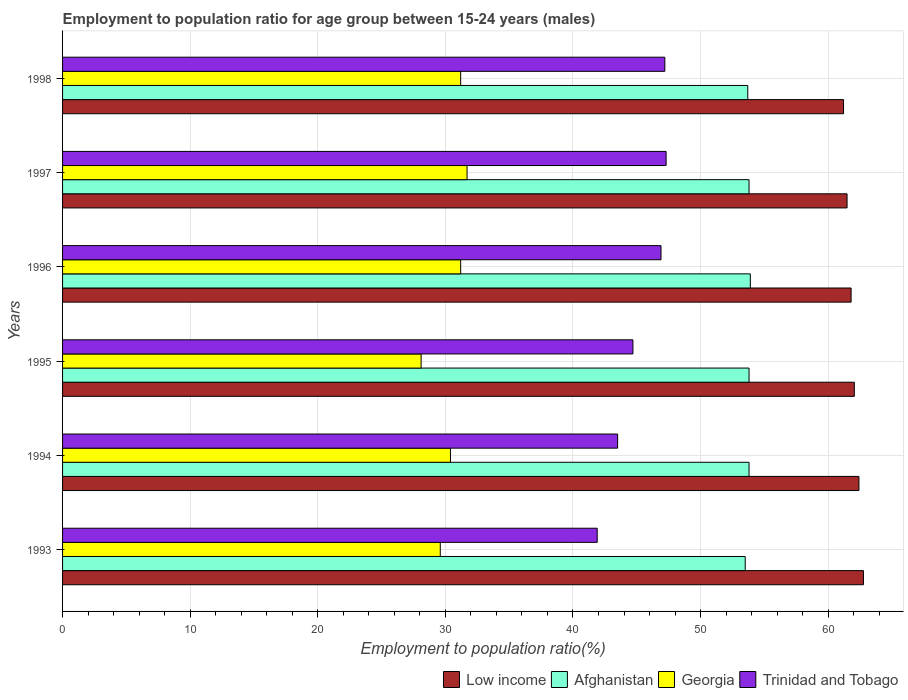Are the number of bars on each tick of the Y-axis equal?
Keep it short and to the point. Yes. How many bars are there on the 5th tick from the bottom?
Offer a terse response. 4. In how many cases, is the number of bars for a given year not equal to the number of legend labels?
Ensure brevity in your answer.  0. What is the employment to population ratio in Georgia in 1997?
Give a very brief answer. 31.7. Across all years, what is the maximum employment to population ratio in Trinidad and Tobago?
Give a very brief answer. 47.3. Across all years, what is the minimum employment to population ratio in Low income?
Make the answer very short. 61.21. What is the total employment to population ratio in Low income in the graph?
Give a very brief answer. 371.71. What is the difference between the employment to population ratio in Georgia in 1994 and that in 1998?
Keep it short and to the point. -0.8. What is the difference between the employment to population ratio in Afghanistan in 1994 and the employment to population ratio in Georgia in 1993?
Your answer should be very brief. 24.2. What is the average employment to population ratio in Low income per year?
Give a very brief answer. 61.95. In the year 1995, what is the difference between the employment to population ratio in Afghanistan and employment to population ratio in Low income?
Your answer should be compact. -8.25. In how many years, is the employment to population ratio in Afghanistan greater than 20 %?
Provide a succinct answer. 6. What is the ratio of the employment to population ratio in Low income in 1995 to that in 1996?
Keep it short and to the point. 1. Is the employment to population ratio in Trinidad and Tobago in 1994 less than that in 1995?
Provide a short and direct response. Yes. Is the difference between the employment to population ratio in Afghanistan in 1994 and 1997 greater than the difference between the employment to population ratio in Low income in 1994 and 1997?
Make the answer very short. No. What is the difference between the highest and the second highest employment to population ratio in Georgia?
Offer a very short reply. 0.5. What is the difference between the highest and the lowest employment to population ratio in Trinidad and Tobago?
Make the answer very short. 5.4. What does the 1st bar from the top in 1994 represents?
Make the answer very short. Trinidad and Tobago. Does the graph contain any zero values?
Ensure brevity in your answer.  No. Where does the legend appear in the graph?
Your response must be concise. Bottom right. How many legend labels are there?
Ensure brevity in your answer.  4. What is the title of the graph?
Ensure brevity in your answer.  Employment to population ratio for age group between 15-24 years (males). Does "Panama" appear as one of the legend labels in the graph?
Give a very brief answer. No. What is the label or title of the X-axis?
Offer a terse response. Employment to population ratio(%). What is the Employment to population ratio(%) of Low income in 1993?
Your response must be concise. 62.77. What is the Employment to population ratio(%) of Afghanistan in 1993?
Provide a short and direct response. 53.5. What is the Employment to population ratio(%) of Georgia in 1993?
Your answer should be very brief. 29.6. What is the Employment to population ratio(%) of Trinidad and Tobago in 1993?
Make the answer very short. 41.9. What is the Employment to population ratio(%) in Low income in 1994?
Make the answer very short. 62.41. What is the Employment to population ratio(%) in Afghanistan in 1994?
Offer a terse response. 53.8. What is the Employment to population ratio(%) of Georgia in 1994?
Your answer should be compact. 30.4. What is the Employment to population ratio(%) in Trinidad and Tobago in 1994?
Offer a very short reply. 43.5. What is the Employment to population ratio(%) in Low income in 1995?
Give a very brief answer. 62.05. What is the Employment to population ratio(%) of Afghanistan in 1995?
Provide a succinct answer. 53.8. What is the Employment to population ratio(%) of Georgia in 1995?
Your response must be concise. 28.1. What is the Employment to population ratio(%) in Trinidad and Tobago in 1995?
Provide a succinct answer. 44.7. What is the Employment to population ratio(%) of Low income in 1996?
Provide a short and direct response. 61.8. What is the Employment to population ratio(%) of Afghanistan in 1996?
Ensure brevity in your answer.  53.9. What is the Employment to population ratio(%) in Georgia in 1996?
Offer a terse response. 31.2. What is the Employment to population ratio(%) of Trinidad and Tobago in 1996?
Your answer should be compact. 46.9. What is the Employment to population ratio(%) in Low income in 1997?
Keep it short and to the point. 61.48. What is the Employment to population ratio(%) of Afghanistan in 1997?
Provide a succinct answer. 53.8. What is the Employment to population ratio(%) in Georgia in 1997?
Keep it short and to the point. 31.7. What is the Employment to population ratio(%) in Trinidad and Tobago in 1997?
Offer a very short reply. 47.3. What is the Employment to population ratio(%) in Low income in 1998?
Give a very brief answer. 61.21. What is the Employment to population ratio(%) in Afghanistan in 1998?
Provide a short and direct response. 53.7. What is the Employment to population ratio(%) of Georgia in 1998?
Give a very brief answer. 31.2. What is the Employment to population ratio(%) of Trinidad and Tobago in 1998?
Make the answer very short. 47.2. Across all years, what is the maximum Employment to population ratio(%) in Low income?
Offer a terse response. 62.77. Across all years, what is the maximum Employment to population ratio(%) in Afghanistan?
Provide a short and direct response. 53.9. Across all years, what is the maximum Employment to population ratio(%) in Georgia?
Provide a succinct answer. 31.7. Across all years, what is the maximum Employment to population ratio(%) in Trinidad and Tobago?
Provide a short and direct response. 47.3. Across all years, what is the minimum Employment to population ratio(%) of Low income?
Provide a succinct answer. 61.21. Across all years, what is the minimum Employment to population ratio(%) of Afghanistan?
Provide a succinct answer. 53.5. Across all years, what is the minimum Employment to population ratio(%) of Georgia?
Provide a succinct answer. 28.1. Across all years, what is the minimum Employment to population ratio(%) of Trinidad and Tobago?
Provide a succinct answer. 41.9. What is the total Employment to population ratio(%) of Low income in the graph?
Offer a very short reply. 371.71. What is the total Employment to population ratio(%) of Afghanistan in the graph?
Offer a very short reply. 322.5. What is the total Employment to population ratio(%) in Georgia in the graph?
Make the answer very short. 182.2. What is the total Employment to population ratio(%) in Trinidad and Tobago in the graph?
Your response must be concise. 271.5. What is the difference between the Employment to population ratio(%) of Low income in 1993 and that in 1994?
Your response must be concise. 0.35. What is the difference between the Employment to population ratio(%) of Georgia in 1993 and that in 1994?
Offer a terse response. -0.8. What is the difference between the Employment to population ratio(%) of Trinidad and Tobago in 1993 and that in 1994?
Keep it short and to the point. -1.6. What is the difference between the Employment to population ratio(%) in Low income in 1993 and that in 1995?
Your answer should be very brief. 0.72. What is the difference between the Employment to population ratio(%) of Trinidad and Tobago in 1993 and that in 1995?
Offer a very short reply. -2.8. What is the difference between the Employment to population ratio(%) of Low income in 1993 and that in 1996?
Give a very brief answer. 0.97. What is the difference between the Employment to population ratio(%) in Georgia in 1993 and that in 1996?
Your answer should be compact. -1.6. What is the difference between the Employment to population ratio(%) in Trinidad and Tobago in 1993 and that in 1996?
Provide a succinct answer. -5. What is the difference between the Employment to population ratio(%) in Low income in 1993 and that in 1997?
Offer a very short reply. 1.28. What is the difference between the Employment to population ratio(%) of Afghanistan in 1993 and that in 1997?
Offer a very short reply. -0.3. What is the difference between the Employment to population ratio(%) in Low income in 1993 and that in 1998?
Your response must be concise. 1.56. What is the difference between the Employment to population ratio(%) of Georgia in 1993 and that in 1998?
Keep it short and to the point. -1.6. What is the difference between the Employment to population ratio(%) in Trinidad and Tobago in 1993 and that in 1998?
Keep it short and to the point. -5.3. What is the difference between the Employment to population ratio(%) of Low income in 1994 and that in 1995?
Provide a short and direct response. 0.36. What is the difference between the Employment to population ratio(%) in Afghanistan in 1994 and that in 1995?
Your answer should be compact. 0. What is the difference between the Employment to population ratio(%) in Trinidad and Tobago in 1994 and that in 1995?
Your response must be concise. -1.2. What is the difference between the Employment to population ratio(%) in Low income in 1994 and that in 1996?
Ensure brevity in your answer.  0.61. What is the difference between the Employment to population ratio(%) of Afghanistan in 1994 and that in 1996?
Your answer should be compact. -0.1. What is the difference between the Employment to population ratio(%) in Low income in 1994 and that in 1997?
Ensure brevity in your answer.  0.93. What is the difference between the Employment to population ratio(%) in Afghanistan in 1994 and that in 1997?
Your answer should be very brief. 0. What is the difference between the Employment to population ratio(%) of Georgia in 1994 and that in 1997?
Provide a short and direct response. -1.3. What is the difference between the Employment to population ratio(%) of Low income in 1994 and that in 1998?
Offer a very short reply. 1.21. What is the difference between the Employment to population ratio(%) in Georgia in 1994 and that in 1998?
Provide a succinct answer. -0.8. What is the difference between the Employment to population ratio(%) of Low income in 1995 and that in 1996?
Your answer should be compact. 0.25. What is the difference between the Employment to population ratio(%) of Georgia in 1995 and that in 1996?
Give a very brief answer. -3.1. What is the difference between the Employment to population ratio(%) in Low income in 1995 and that in 1997?
Offer a very short reply. 0.57. What is the difference between the Employment to population ratio(%) in Low income in 1995 and that in 1998?
Provide a short and direct response. 0.84. What is the difference between the Employment to population ratio(%) in Afghanistan in 1995 and that in 1998?
Keep it short and to the point. 0.1. What is the difference between the Employment to population ratio(%) of Trinidad and Tobago in 1995 and that in 1998?
Give a very brief answer. -2.5. What is the difference between the Employment to population ratio(%) of Low income in 1996 and that in 1997?
Offer a very short reply. 0.32. What is the difference between the Employment to population ratio(%) in Georgia in 1996 and that in 1997?
Make the answer very short. -0.5. What is the difference between the Employment to population ratio(%) in Trinidad and Tobago in 1996 and that in 1997?
Your answer should be compact. -0.4. What is the difference between the Employment to population ratio(%) of Low income in 1996 and that in 1998?
Provide a short and direct response. 0.59. What is the difference between the Employment to population ratio(%) in Afghanistan in 1996 and that in 1998?
Provide a succinct answer. 0.2. What is the difference between the Employment to population ratio(%) in Low income in 1997 and that in 1998?
Your answer should be compact. 0.28. What is the difference between the Employment to population ratio(%) in Afghanistan in 1997 and that in 1998?
Provide a short and direct response. 0.1. What is the difference between the Employment to population ratio(%) of Georgia in 1997 and that in 1998?
Your answer should be compact. 0.5. What is the difference between the Employment to population ratio(%) in Low income in 1993 and the Employment to population ratio(%) in Afghanistan in 1994?
Offer a very short reply. 8.97. What is the difference between the Employment to population ratio(%) in Low income in 1993 and the Employment to population ratio(%) in Georgia in 1994?
Your answer should be compact. 32.37. What is the difference between the Employment to population ratio(%) of Low income in 1993 and the Employment to population ratio(%) of Trinidad and Tobago in 1994?
Your response must be concise. 19.27. What is the difference between the Employment to population ratio(%) in Afghanistan in 1993 and the Employment to population ratio(%) in Georgia in 1994?
Keep it short and to the point. 23.1. What is the difference between the Employment to population ratio(%) of Georgia in 1993 and the Employment to population ratio(%) of Trinidad and Tobago in 1994?
Offer a terse response. -13.9. What is the difference between the Employment to population ratio(%) in Low income in 1993 and the Employment to population ratio(%) in Afghanistan in 1995?
Provide a short and direct response. 8.97. What is the difference between the Employment to population ratio(%) of Low income in 1993 and the Employment to population ratio(%) of Georgia in 1995?
Give a very brief answer. 34.67. What is the difference between the Employment to population ratio(%) of Low income in 1993 and the Employment to population ratio(%) of Trinidad and Tobago in 1995?
Keep it short and to the point. 18.07. What is the difference between the Employment to population ratio(%) of Afghanistan in 1993 and the Employment to population ratio(%) of Georgia in 1995?
Your response must be concise. 25.4. What is the difference between the Employment to population ratio(%) in Georgia in 1993 and the Employment to population ratio(%) in Trinidad and Tobago in 1995?
Your answer should be very brief. -15.1. What is the difference between the Employment to population ratio(%) in Low income in 1993 and the Employment to population ratio(%) in Afghanistan in 1996?
Offer a terse response. 8.87. What is the difference between the Employment to population ratio(%) of Low income in 1993 and the Employment to population ratio(%) of Georgia in 1996?
Your answer should be very brief. 31.57. What is the difference between the Employment to population ratio(%) in Low income in 1993 and the Employment to population ratio(%) in Trinidad and Tobago in 1996?
Provide a succinct answer. 15.87. What is the difference between the Employment to population ratio(%) in Afghanistan in 1993 and the Employment to population ratio(%) in Georgia in 1996?
Your answer should be very brief. 22.3. What is the difference between the Employment to population ratio(%) in Georgia in 1993 and the Employment to population ratio(%) in Trinidad and Tobago in 1996?
Ensure brevity in your answer.  -17.3. What is the difference between the Employment to population ratio(%) of Low income in 1993 and the Employment to population ratio(%) of Afghanistan in 1997?
Make the answer very short. 8.97. What is the difference between the Employment to population ratio(%) in Low income in 1993 and the Employment to population ratio(%) in Georgia in 1997?
Your answer should be compact. 31.07. What is the difference between the Employment to population ratio(%) of Low income in 1993 and the Employment to population ratio(%) of Trinidad and Tobago in 1997?
Your answer should be compact. 15.47. What is the difference between the Employment to population ratio(%) in Afghanistan in 1993 and the Employment to population ratio(%) in Georgia in 1997?
Make the answer very short. 21.8. What is the difference between the Employment to population ratio(%) in Georgia in 1993 and the Employment to population ratio(%) in Trinidad and Tobago in 1997?
Your answer should be compact. -17.7. What is the difference between the Employment to population ratio(%) in Low income in 1993 and the Employment to population ratio(%) in Afghanistan in 1998?
Provide a succinct answer. 9.07. What is the difference between the Employment to population ratio(%) in Low income in 1993 and the Employment to population ratio(%) in Georgia in 1998?
Your answer should be very brief. 31.57. What is the difference between the Employment to population ratio(%) of Low income in 1993 and the Employment to population ratio(%) of Trinidad and Tobago in 1998?
Your response must be concise. 15.57. What is the difference between the Employment to population ratio(%) of Afghanistan in 1993 and the Employment to population ratio(%) of Georgia in 1998?
Provide a short and direct response. 22.3. What is the difference between the Employment to population ratio(%) of Afghanistan in 1993 and the Employment to population ratio(%) of Trinidad and Tobago in 1998?
Your answer should be compact. 6.3. What is the difference between the Employment to population ratio(%) of Georgia in 1993 and the Employment to population ratio(%) of Trinidad and Tobago in 1998?
Ensure brevity in your answer.  -17.6. What is the difference between the Employment to population ratio(%) in Low income in 1994 and the Employment to population ratio(%) in Afghanistan in 1995?
Your answer should be very brief. 8.61. What is the difference between the Employment to population ratio(%) of Low income in 1994 and the Employment to population ratio(%) of Georgia in 1995?
Your answer should be compact. 34.31. What is the difference between the Employment to population ratio(%) in Low income in 1994 and the Employment to population ratio(%) in Trinidad and Tobago in 1995?
Give a very brief answer. 17.71. What is the difference between the Employment to population ratio(%) in Afghanistan in 1994 and the Employment to population ratio(%) in Georgia in 1995?
Give a very brief answer. 25.7. What is the difference between the Employment to population ratio(%) in Georgia in 1994 and the Employment to population ratio(%) in Trinidad and Tobago in 1995?
Your answer should be very brief. -14.3. What is the difference between the Employment to population ratio(%) of Low income in 1994 and the Employment to population ratio(%) of Afghanistan in 1996?
Your answer should be very brief. 8.51. What is the difference between the Employment to population ratio(%) of Low income in 1994 and the Employment to population ratio(%) of Georgia in 1996?
Provide a short and direct response. 31.21. What is the difference between the Employment to population ratio(%) in Low income in 1994 and the Employment to population ratio(%) in Trinidad and Tobago in 1996?
Offer a terse response. 15.51. What is the difference between the Employment to population ratio(%) of Afghanistan in 1994 and the Employment to population ratio(%) of Georgia in 1996?
Offer a terse response. 22.6. What is the difference between the Employment to population ratio(%) in Georgia in 1994 and the Employment to population ratio(%) in Trinidad and Tobago in 1996?
Keep it short and to the point. -16.5. What is the difference between the Employment to population ratio(%) in Low income in 1994 and the Employment to population ratio(%) in Afghanistan in 1997?
Your answer should be very brief. 8.61. What is the difference between the Employment to population ratio(%) in Low income in 1994 and the Employment to population ratio(%) in Georgia in 1997?
Offer a terse response. 30.71. What is the difference between the Employment to population ratio(%) of Low income in 1994 and the Employment to population ratio(%) of Trinidad and Tobago in 1997?
Make the answer very short. 15.11. What is the difference between the Employment to population ratio(%) in Afghanistan in 1994 and the Employment to population ratio(%) in Georgia in 1997?
Ensure brevity in your answer.  22.1. What is the difference between the Employment to population ratio(%) of Georgia in 1994 and the Employment to population ratio(%) of Trinidad and Tobago in 1997?
Offer a very short reply. -16.9. What is the difference between the Employment to population ratio(%) of Low income in 1994 and the Employment to population ratio(%) of Afghanistan in 1998?
Offer a very short reply. 8.71. What is the difference between the Employment to population ratio(%) in Low income in 1994 and the Employment to population ratio(%) in Georgia in 1998?
Your response must be concise. 31.21. What is the difference between the Employment to population ratio(%) of Low income in 1994 and the Employment to population ratio(%) of Trinidad and Tobago in 1998?
Offer a terse response. 15.21. What is the difference between the Employment to population ratio(%) in Afghanistan in 1994 and the Employment to population ratio(%) in Georgia in 1998?
Keep it short and to the point. 22.6. What is the difference between the Employment to population ratio(%) of Georgia in 1994 and the Employment to population ratio(%) of Trinidad and Tobago in 1998?
Ensure brevity in your answer.  -16.8. What is the difference between the Employment to population ratio(%) in Low income in 1995 and the Employment to population ratio(%) in Afghanistan in 1996?
Your answer should be very brief. 8.15. What is the difference between the Employment to population ratio(%) of Low income in 1995 and the Employment to population ratio(%) of Georgia in 1996?
Your answer should be compact. 30.85. What is the difference between the Employment to population ratio(%) in Low income in 1995 and the Employment to population ratio(%) in Trinidad and Tobago in 1996?
Offer a very short reply. 15.15. What is the difference between the Employment to population ratio(%) of Afghanistan in 1995 and the Employment to population ratio(%) of Georgia in 1996?
Make the answer very short. 22.6. What is the difference between the Employment to population ratio(%) of Georgia in 1995 and the Employment to population ratio(%) of Trinidad and Tobago in 1996?
Ensure brevity in your answer.  -18.8. What is the difference between the Employment to population ratio(%) of Low income in 1995 and the Employment to population ratio(%) of Afghanistan in 1997?
Offer a terse response. 8.25. What is the difference between the Employment to population ratio(%) in Low income in 1995 and the Employment to population ratio(%) in Georgia in 1997?
Make the answer very short. 30.35. What is the difference between the Employment to population ratio(%) in Low income in 1995 and the Employment to population ratio(%) in Trinidad and Tobago in 1997?
Your answer should be compact. 14.75. What is the difference between the Employment to population ratio(%) of Afghanistan in 1995 and the Employment to population ratio(%) of Georgia in 1997?
Give a very brief answer. 22.1. What is the difference between the Employment to population ratio(%) of Georgia in 1995 and the Employment to population ratio(%) of Trinidad and Tobago in 1997?
Ensure brevity in your answer.  -19.2. What is the difference between the Employment to population ratio(%) in Low income in 1995 and the Employment to population ratio(%) in Afghanistan in 1998?
Your answer should be compact. 8.35. What is the difference between the Employment to population ratio(%) in Low income in 1995 and the Employment to population ratio(%) in Georgia in 1998?
Your response must be concise. 30.85. What is the difference between the Employment to population ratio(%) of Low income in 1995 and the Employment to population ratio(%) of Trinidad and Tobago in 1998?
Your response must be concise. 14.85. What is the difference between the Employment to population ratio(%) in Afghanistan in 1995 and the Employment to population ratio(%) in Georgia in 1998?
Provide a succinct answer. 22.6. What is the difference between the Employment to population ratio(%) of Georgia in 1995 and the Employment to population ratio(%) of Trinidad and Tobago in 1998?
Offer a terse response. -19.1. What is the difference between the Employment to population ratio(%) of Low income in 1996 and the Employment to population ratio(%) of Afghanistan in 1997?
Your answer should be very brief. 8. What is the difference between the Employment to population ratio(%) in Low income in 1996 and the Employment to population ratio(%) in Georgia in 1997?
Make the answer very short. 30.1. What is the difference between the Employment to population ratio(%) of Low income in 1996 and the Employment to population ratio(%) of Trinidad and Tobago in 1997?
Your response must be concise. 14.5. What is the difference between the Employment to population ratio(%) in Afghanistan in 1996 and the Employment to population ratio(%) in Georgia in 1997?
Make the answer very short. 22.2. What is the difference between the Employment to population ratio(%) of Afghanistan in 1996 and the Employment to population ratio(%) of Trinidad and Tobago in 1997?
Ensure brevity in your answer.  6.6. What is the difference between the Employment to population ratio(%) in Georgia in 1996 and the Employment to population ratio(%) in Trinidad and Tobago in 1997?
Your answer should be very brief. -16.1. What is the difference between the Employment to population ratio(%) in Low income in 1996 and the Employment to population ratio(%) in Afghanistan in 1998?
Provide a succinct answer. 8.1. What is the difference between the Employment to population ratio(%) in Low income in 1996 and the Employment to population ratio(%) in Georgia in 1998?
Make the answer very short. 30.6. What is the difference between the Employment to population ratio(%) in Low income in 1996 and the Employment to population ratio(%) in Trinidad and Tobago in 1998?
Your response must be concise. 14.6. What is the difference between the Employment to population ratio(%) of Afghanistan in 1996 and the Employment to population ratio(%) of Georgia in 1998?
Provide a short and direct response. 22.7. What is the difference between the Employment to population ratio(%) in Afghanistan in 1996 and the Employment to population ratio(%) in Trinidad and Tobago in 1998?
Provide a succinct answer. 6.7. What is the difference between the Employment to population ratio(%) in Georgia in 1996 and the Employment to population ratio(%) in Trinidad and Tobago in 1998?
Your answer should be compact. -16. What is the difference between the Employment to population ratio(%) of Low income in 1997 and the Employment to population ratio(%) of Afghanistan in 1998?
Keep it short and to the point. 7.78. What is the difference between the Employment to population ratio(%) in Low income in 1997 and the Employment to population ratio(%) in Georgia in 1998?
Your answer should be compact. 30.28. What is the difference between the Employment to population ratio(%) of Low income in 1997 and the Employment to population ratio(%) of Trinidad and Tobago in 1998?
Your answer should be very brief. 14.28. What is the difference between the Employment to population ratio(%) of Afghanistan in 1997 and the Employment to population ratio(%) of Georgia in 1998?
Your response must be concise. 22.6. What is the difference between the Employment to population ratio(%) in Georgia in 1997 and the Employment to population ratio(%) in Trinidad and Tobago in 1998?
Your answer should be compact. -15.5. What is the average Employment to population ratio(%) of Low income per year?
Ensure brevity in your answer.  61.95. What is the average Employment to population ratio(%) in Afghanistan per year?
Your answer should be compact. 53.75. What is the average Employment to population ratio(%) in Georgia per year?
Keep it short and to the point. 30.37. What is the average Employment to population ratio(%) of Trinidad and Tobago per year?
Give a very brief answer. 45.25. In the year 1993, what is the difference between the Employment to population ratio(%) of Low income and Employment to population ratio(%) of Afghanistan?
Keep it short and to the point. 9.27. In the year 1993, what is the difference between the Employment to population ratio(%) in Low income and Employment to population ratio(%) in Georgia?
Offer a very short reply. 33.17. In the year 1993, what is the difference between the Employment to population ratio(%) of Low income and Employment to population ratio(%) of Trinidad and Tobago?
Give a very brief answer. 20.87. In the year 1993, what is the difference between the Employment to population ratio(%) of Afghanistan and Employment to population ratio(%) of Georgia?
Ensure brevity in your answer.  23.9. In the year 1993, what is the difference between the Employment to population ratio(%) in Georgia and Employment to population ratio(%) in Trinidad and Tobago?
Provide a succinct answer. -12.3. In the year 1994, what is the difference between the Employment to population ratio(%) in Low income and Employment to population ratio(%) in Afghanistan?
Offer a very short reply. 8.61. In the year 1994, what is the difference between the Employment to population ratio(%) of Low income and Employment to population ratio(%) of Georgia?
Provide a short and direct response. 32.01. In the year 1994, what is the difference between the Employment to population ratio(%) of Low income and Employment to population ratio(%) of Trinidad and Tobago?
Your response must be concise. 18.91. In the year 1994, what is the difference between the Employment to population ratio(%) of Afghanistan and Employment to population ratio(%) of Georgia?
Offer a terse response. 23.4. In the year 1994, what is the difference between the Employment to population ratio(%) in Afghanistan and Employment to population ratio(%) in Trinidad and Tobago?
Keep it short and to the point. 10.3. In the year 1995, what is the difference between the Employment to population ratio(%) of Low income and Employment to population ratio(%) of Afghanistan?
Give a very brief answer. 8.25. In the year 1995, what is the difference between the Employment to population ratio(%) of Low income and Employment to population ratio(%) of Georgia?
Provide a succinct answer. 33.95. In the year 1995, what is the difference between the Employment to population ratio(%) of Low income and Employment to population ratio(%) of Trinidad and Tobago?
Make the answer very short. 17.35. In the year 1995, what is the difference between the Employment to population ratio(%) in Afghanistan and Employment to population ratio(%) in Georgia?
Your answer should be very brief. 25.7. In the year 1995, what is the difference between the Employment to population ratio(%) of Georgia and Employment to population ratio(%) of Trinidad and Tobago?
Your response must be concise. -16.6. In the year 1996, what is the difference between the Employment to population ratio(%) of Low income and Employment to population ratio(%) of Afghanistan?
Offer a very short reply. 7.9. In the year 1996, what is the difference between the Employment to population ratio(%) in Low income and Employment to population ratio(%) in Georgia?
Give a very brief answer. 30.6. In the year 1996, what is the difference between the Employment to population ratio(%) in Low income and Employment to population ratio(%) in Trinidad and Tobago?
Ensure brevity in your answer.  14.9. In the year 1996, what is the difference between the Employment to population ratio(%) in Afghanistan and Employment to population ratio(%) in Georgia?
Provide a succinct answer. 22.7. In the year 1996, what is the difference between the Employment to population ratio(%) of Afghanistan and Employment to population ratio(%) of Trinidad and Tobago?
Give a very brief answer. 7. In the year 1996, what is the difference between the Employment to population ratio(%) of Georgia and Employment to population ratio(%) of Trinidad and Tobago?
Keep it short and to the point. -15.7. In the year 1997, what is the difference between the Employment to population ratio(%) in Low income and Employment to population ratio(%) in Afghanistan?
Ensure brevity in your answer.  7.68. In the year 1997, what is the difference between the Employment to population ratio(%) of Low income and Employment to population ratio(%) of Georgia?
Your response must be concise. 29.78. In the year 1997, what is the difference between the Employment to population ratio(%) in Low income and Employment to population ratio(%) in Trinidad and Tobago?
Provide a succinct answer. 14.18. In the year 1997, what is the difference between the Employment to population ratio(%) of Afghanistan and Employment to population ratio(%) of Georgia?
Provide a short and direct response. 22.1. In the year 1997, what is the difference between the Employment to population ratio(%) of Afghanistan and Employment to population ratio(%) of Trinidad and Tobago?
Give a very brief answer. 6.5. In the year 1997, what is the difference between the Employment to population ratio(%) of Georgia and Employment to population ratio(%) of Trinidad and Tobago?
Give a very brief answer. -15.6. In the year 1998, what is the difference between the Employment to population ratio(%) of Low income and Employment to population ratio(%) of Afghanistan?
Offer a terse response. 7.51. In the year 1998, what is the difference between the Employment to population ratio(%) in Low income and Employment to population ratio(%) in Georgia?
Keep it short and to the point. 30.01. In the year 1998, what is the difference between the Employment to population ratio(%) of Low income and Employment to population ratio(%) of Trinidad and Tobago?
Make the answer very short. 14.01. In the year 1998, what is the difference between the Employment to population ratio(%) of Afghanistan and Employment to population ratio(%) of Georgia?
Your response must be concise. 22.5. In the year 1998, what is the difference between the Employment to population ratio(%) in Georgia and Employment to population ratio(%) in Trinidad and Tobago?
Make the answer very short. -16. What is the ratio of the Employment to population ratio(%) in Afghanistan in 1993 to that in 1994?
Give a very brief answer. 0.99. What is the ratio of the Employment to population ratio(%) of Georgia in 1993 to that in 1994?
Offer a very short reply. 0.97. What is the ratio of the Employment to population ratio(%) in Trinidad and Tobago in 1993 to that in 1994?
Your answer should be compact. 0.96. What is the ratio of the Employment to population ratio(%) of Low income in 1993 to that in 1995?
Provide a short and direct response. 1.01. What is the ratio of the Employment to population ratio(%) of Georgia in 1993 to that in 1995?
Keep it short and to the point. 1.05. What is the ratio of the Employment to population ratio(%) in Trinidad and Tobago in 1993 to that in 1995?
Offer a very short reply. 0.94. What is the ratio of the Employment to population ratio(%) in Low income in 1993 to that in 1996?
Offer a terse response. 1.02. What is the ratio of the Employment to population ratio(%) of Georgia in 1993 to that in 1996?
Your answer should be compact. 0.95. What is the ratio of the Employment to population ratio(%) in Trinidad and Tobago in 1993 to that in 1996?
Your answer should be very brief. 0.89. What is the ratio of the Employment to population ratio(%) in Low income in 1993 to that in 1997?
Your answer should be very brief. 1.02. What is the ratio of the Employment to population ratio(%) in Afghanistan in 1993 to that in 1997?
Ensure brevity in your answer.  0.99. What is the ratio of the Employment to population ratio(%) of Georgia in 1993 to that in 1997?
Offer a terse response. 0.93. What is the ratio of the Employment to population ratio(%) of Trinidad and Tobago in 1993 to that in 1997?
Offer a terse response. 0.89. What is the ratio of the Employment to population ratio(%) in Low income in 1993 to that in 1998?
Your response must be concise. 1.03. What is the ratio of the Employment to population ratio(%) in Afghanistan in 1993 to that in 1998?
Offer a terse response. 1. What is the ratio of the Employment to population ratio(%) in Georgia in 1993 to that in 1998?
Offer a very short reply. 0.95. What is the ratio of the Employment to population ratio(%) of Trinidad and Tobago in 1993 to that in 1998?
Provide a short and direct response. 0.89. What is the ratio of the Employment to population ratio(%) in Georgia in 1994 to that in 1995?
Give a very brief answer. 1.08. What is the ratio of the Employment to population ratio(%) of Trinidad and Tobago in 1994 to that in 1995?
Offer a terse response. 0.97. What is the ratio of the Employment to population ratio(%) of Afghanistan in 1994 to that in 1996?
Your answer should be compact. 1. What is the ratio of the Employment to population ratio(%) in Georgia in 1994 to that in 1996?
Offer a very short reply. 0.97. What is the ratio of the Employment to population ratio(%) of Trinidad and Tobago in 1994 to that in 1996?
Ensure brevity in your answer.  0.93. What is the ratio of the Employment to population ratio(%) in Low income in 1994 to that in 1997?
Keep it short and to the point. 1.02. What is the ratio of the Employment to population ratio(%) of Afghanistan in 1994 to that in 1997?
Ensure brevity in your answer.  1. What is the ratio of the Employment to population ratio(%) in Trinidad and Tobago in 1994 to that in 1997?
Ensure brevity in your answer.  0.92. What is the ratio of the Employment to population ratio(%) of Low income in 1994 to that in 1998?
Make the answer very short. 1.02. What is the ratio of the Employment to population ratio(%) in Afghanistan in 1994 to that in 1998?
Offer a terse response. 1. What is the ratio of the Employment to population ratio(%) in Georgia in 1994 to that in 1998?
Offer a very short reply. 0.97. What is the ratio of the Employment to population ratio(%) in Trinidad and Tobago in 1994 to that in 1998?
Provide a succinct answer. 0.92. What is the ratio of the Employment to population ratio(%) in Low income in 1995 to that in 1996?
Your answer should be compact. 1. What is the ratio of the Employment to population ratio(%) of Georgia in 1995 to that in 1996?
Provide a succinct answer. 0.9. What is the ratio of the Employment to population ratio(%) in Trinidad and Tobago in 1995 to that in 1996?
Your answer should be compact. 0.95. What is the ratio of the Employment to population ratio(%) of Low income in 1995 to that in 1997?
Provide a succinct answer. 1.01. What is the ratio of the Employment to population ratio(%) in Georgia in 1995 to that in 1997?
Your response must be concise. 0.89. What is the ratio of the Employment to population ratio(%) of Trinidad and Tobago in 1995 to that in 1997?
Keep it short and to the point. 0.94. What is the ratio of the Employment to population ratio(%) of Low income in 1995 to that in 1998?
Keep it short and to the point. 1.01. What is the ratio of the Employment to population ratio(%) in Afghanistan in 1995 to that in 1998?
Make the answer very short. 1. What is the ratio of the Employment to population ratio(%) of Georgia in 1995 to that in 1998?
Provide a short and direct response. 0.9. What is the ratio of the Employment to population ratio(%) in Trinidad and Tobago in 1995 to that in 1998?
Your answer should be very brief. 0.95. What is the ratio of the Employment to population ratio(%) in Low income in 1996 to that in 1997?
Keep it short and to the point. 1.01. What is the ratio of the Employment to population ratio(%) in Georgia in 1996 to that in 1997?
Ensure brevity in your answer.  0.98. What is the ratio of the Employment to population ratio(%) in Low income in 1996 to that in 1998?
Make the answer very short. 1.01. What is the ratio of the Employment to population ratio(%) in Low income in 1997 to that in 1998?
Offer a very short reply. 1. What is the ratio of the Employment to population ratio(%) in Afghanistan in 1997 to that in 1998?
Give a very brief answer. 1. What is the ratio of the Employment to population ratio(%) in Georgia in 1997 to that in 1998?
Your answer should be very brief. 1.02. What is the ratio of the Employment to population ratio(%) of Trinidad and Tobago in 1997 to that in 1998?
Provide a succinct answer. 1. What is the difference between the highest and the second highest Employment to population ratio(%) in Low income?
Provide a short and direct response. 0.35. What is the difference between the highest and the second highest Employment to population ratio(%) in Afghanistan?
Your answer should be compact. 0.1. What is the difference between the highest and the lowest Employment to population ratio(%) of Low income?
Offer a very short reply. 1.56. What is the difference between the highest and the lowest Employment to population ratio(%) of Georgia?
Your response must be concise. 3.6. 